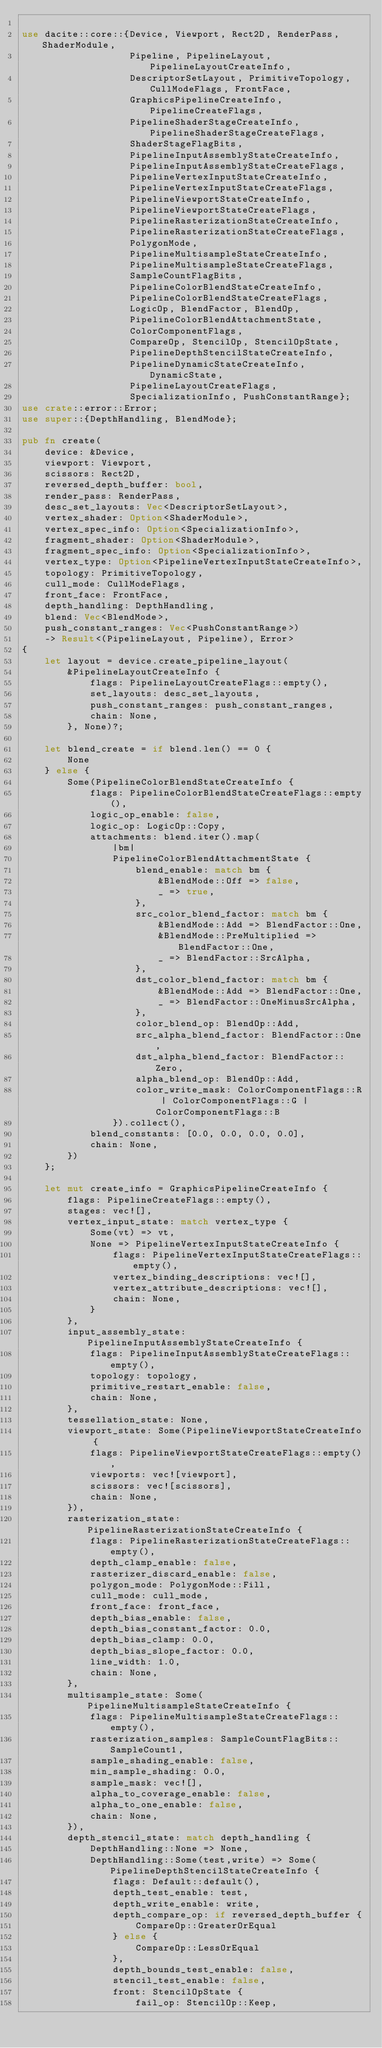<code> <loc_0><loc_0><loc_500><loc_500><_Rust_>
use dacite::core::{Device, Viewport, Rect2D, RenderPass, ShaderModule,
                   Pipeline, PipelineLayout, PipelineLayoutCreateInfo,
                   DescriptorSetLayout, PrimitiveTopology, CullModeFlags, FrontFace,
                   GraphicsPipelineCreateInfo, PipelineCreateFlags,
                   PipelineShaderStageCreateInfo, PipelineShaderStageCreateFlags,
                   ShaderStageFlagBits,
                   PipelineInputAssemblyStateCreateInfo,
                   PipelineInputAssemblyStateCreateFlags,
                   PipelineVertexInputStateCreateInfo,
                   PipelineVertexInputStateCreateFlags,
                   PipelineViewportStateCreateInfo,
                   PipelineViewportStateCreateFlags,
                   PipelineRasterizationStateCreateInfo,
                   PipelineRasterizationStateCreateFlags,
                   PolygonMode,
                   PipelineMultisampleStateCreateInfo,
                   PipelineMultisampleStateCreateFlags,
                   SampleCountFlagBits,
                   PipelineColorBlendStateCreateInfo,
                   PipelineColorBlendStateCreateFlags,
                   LogicOp, BlendFactor, BlendOp,
                   PipelineColorBlendAttachmentState,
                   ColorComponentFlags,
                   CompareOp, StencilOp, StencilOpState,
                   PipelineDepthStencilStateCreateInfo,
                   PipelineDynamicStateCreateInfo, DynamicState,
                   PipelineLayoutCreateFlags,
                   SpecializationInfo, PushConstantRange};
use crate::error::Error;
use super::{DepthHandling, BlendMode};

pub fn create(
    device: &Device,
    viewport: Viewport,
    scissors: Rect2D,
    reversed_depth_buffer: bool,
    render_pass: RenderPass,
    desc_set_layouts: Vec<DescriptorSetLayout>,
    vertex_shader: Option<ShaderModule>,
    vertex_spec_info: Option<SpecializationInfo>,
    fragment_shader: Option<ShaderModule>,
    fragment_spec_info: Option<SpecializationInfo>,
    vertex_type: Option<PipelineVertexInputStateCreateInfo>,
    topology: PrimitiveTopology,
    cull_mode: CullModeFlags,
    front_face: FrontFace,
    depth_handling: DepthHandling,
    blend: Vec<BlendMode>,
    push_constant_ranges: Vec<PushConstantRange>)
    -> Result<(PipelineLayout, Pipeline), Error>
{
    let layout = device.create_pipeline_layout(
        &PipelineLayoutCreateInfo {
            flags: PipelineLayoutCreateFlags::empty(),
            set_layouts: desc_set_layouts,
            push_constant_ranges: push_constant_ranges,
            chain: None,
        }, None)?;

    let blend_create = if blend.len() == 0 {
        None
    } else {
        Some(PipelineColorBlendStateCreateInfo {
            flags: PipelineColorBlendStateCreateFlags::empty(),
            logic_op_enable: false,
            logic_op: LogicOp::Copy,
            attachments: blend.iter().map(
                |bm|
                PipelineColorBlendAttachmentState {
                    blend_enable: match bm {
                        &BlendMode::Off => false,
                        _ => true,
                    },
                    src_color_blend_factor: match bm {
                        &BlendMode::Add => BlendFactor::One,
                        &BlendMode::PreMultiplied => BlendFactor::One,
                        _ => BlendFactor::SrcAlpha,
                    },
                    dst_color_blend_factor: match bm {
                        &BlendMode::Add => BlendFactor::One,
                        _ => BlendFactor::OneMinusSrcAlpha,
                    },
                    color_blend_op: BlendOp::Add,
                    src_alpha_blend_factor: BlendFactor::One,
                    dst_alpha_blend_factor: BlendFactor::Zero,
                    alpha_blend_op: BlendOp::Add,
                    color_write_mask: ColorComponentFlags::R | ColorComponentFlags::G | ColorComponentFlags::B
                }).collect(),
            blend_constants: [0.0, 0.0, 0.0, 0.0],
            chain: None,
        })
    };

    let mut create_info = GraphicsPipelineCreateInfo {
        flags: PipelineCreateFlags::empty(),
        stages: vec![],
        vertex_input_state: match vertex_type {
            Some(vt) => vt,
            None => PipelineVertexInputStateCreateInfo {
                flags: PipelineVertexInputStateCreateFlags::empty(),
                vertex_binding_descriptions: vec![],
                vertex_attribute_descriptions: vec![],
                chain: None,
            }
        },
        input_assembly_state: PipelineInputAssemblyStateCreateInfo {
            flags: PipelineInputAssemblyStateCreateFlags::empty(),
            topology: topology,
            primitive_restart_enable: false,
            chain: None,
        },
        tessellation_state: None,
        viewport_state: Some(PipelineViewportStateCreateInfo {
            flags: PipelineViewportStateCreateFlags::empty(),
            viewports: vec![viewport],
            scissors: vec![scissors],
            chain: None,
        }),
        rasterization_state: PipelineRasterizationStateCreateInfo {
            flags: PipelineRasterizationStateCreateFlags::empty(),
            depth_clamp_enable: false,
            rasterizer_discard_enable: false,
            polygon_mode: PolygonMode::Fill,
            cull_mode: cull_mode,
            front_face: front_face,
            depth_bias_enable: false,
            depth_bias_constant_factor: 0.0,
            depth_bias_clamp: 0.0,
            depth_bias_slope_factor: 0.0,
            line_width: 1.0,
            chain: None,
        },
        multisample_state: Some(PipelineMultisampleStateCreateInfo {
            flags: PipelineMultisampleStateCreateFlags::empty(),
            rasterization_samples: SampleCountFlagBits::SampleCount1,
            sample_shading_enable: false,
            min_sample_shading: 0.0,
            sample_mask: vec![],
            alpha_to_coverage_enable: false,
            alpha_to_one_enable: false,
            chain: None,
        }),
        depth_stencil_state: match depth_handling {
            DepthHandling::None => None,
            DepthHandling::Some(test,write) => Some(PipelineDepthStencilStateCreateInfo {
                flags: Default::default(),
                depth_test_enable: test,
                depth_write_enable: write,
                depth_compare_op: if reversed_depth_buffer {
                    CompareOp::GreaterOrEqual
                } else {
                    CompareOp::LessOrEqual
                },
                depth_bounds_test_enable: false,
                stencil_test_enable: false,
                front: StencilOpState {
                    fail_op: StencilOp::Keep,</code> 